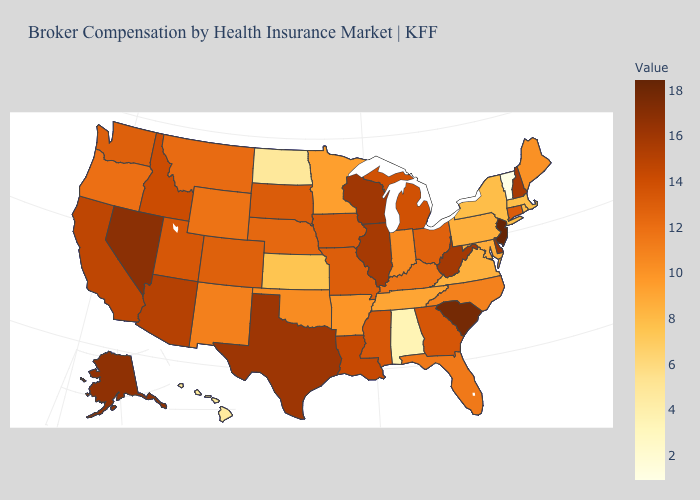Does New Jersey have the highest value in the USA?
Answer briefly. Yes. Among the states that border Idaho , does Washington have the lowest value?
Concise answer only. No. Does Tennessee have a lower value than Oregon?
Concise answer only. Yes. Does New Jersey have the highest value in the USA?
Answer briefly. Yes. Which states hav the highest value in the MidWest?
Keep it brief. Wisconsin. 